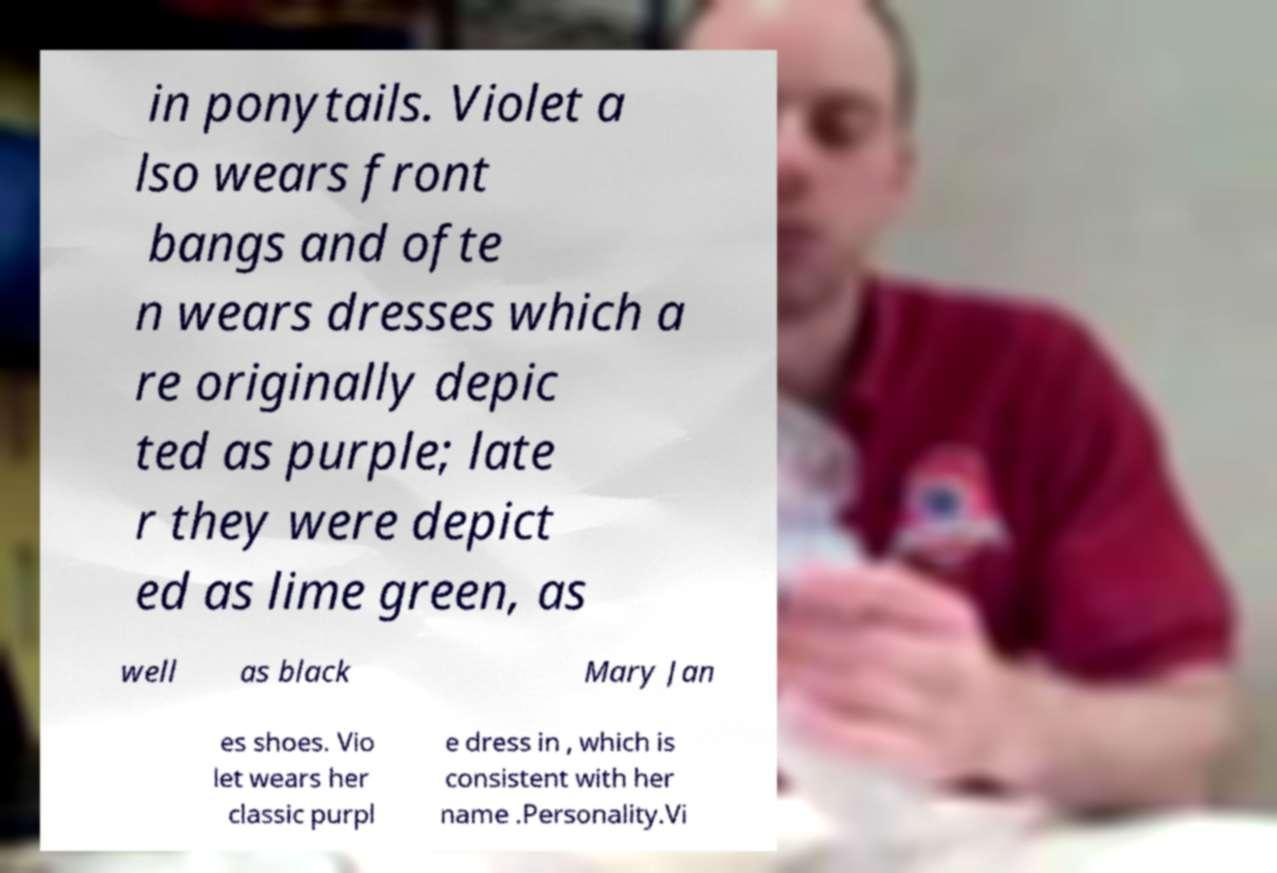Please identify and transcribe the text found in this image. in ponytails. Violet a lso wears front bangs and ofte n wears dresses which a re originally depic ted as purple; late r they were depict ed as lime green, as well as black Mary Jan es shoes. Vio let wears her classic purpl e dress in , which is consistent with her name .Personality.Vi 